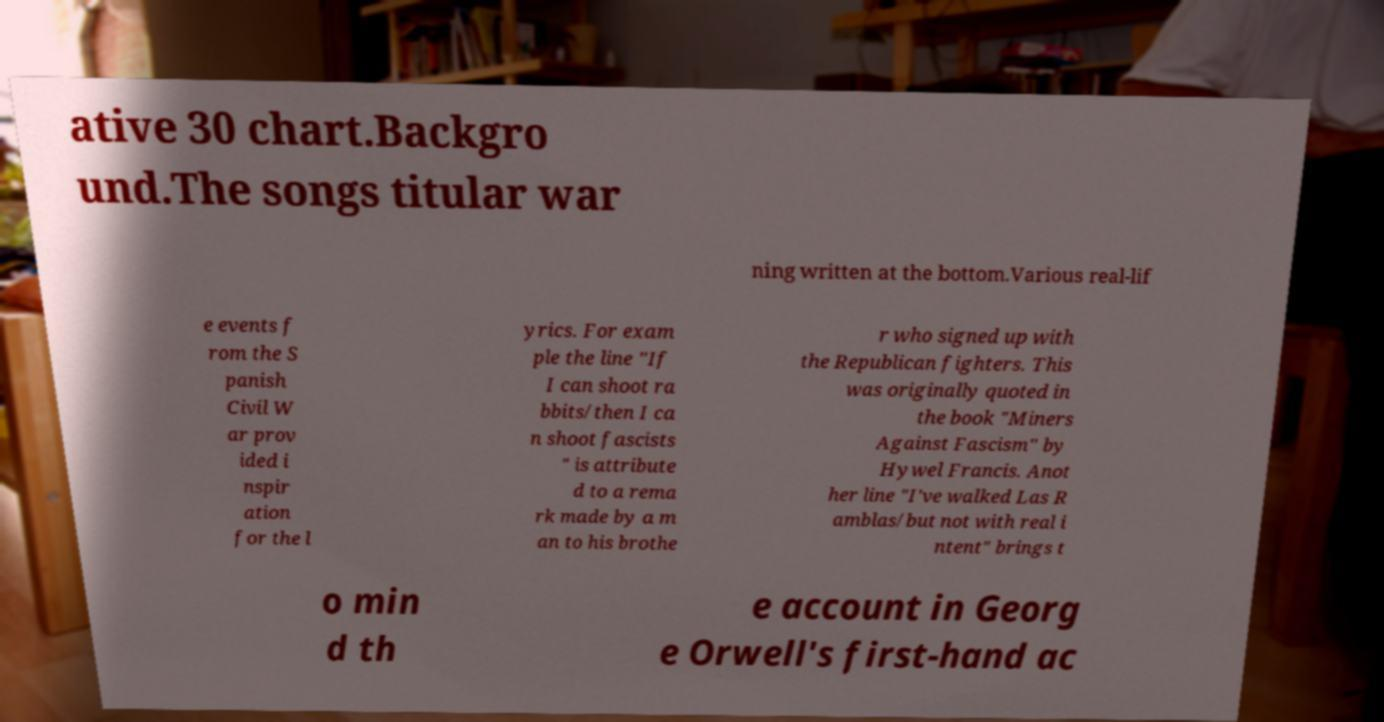I need the written content from this picture converted into text. Can you do that? ative 30 chart.Backgro und.The songs titular war ning written at the bottom.Various real-lif e events f rom the S panish Civil W ar prov ided i nspir ation for the l yrics. For exam ple the line "If I can shoot ra bbits/then I ca n shoot fascists " is attribute d to a rema rk made by a m an to his brothe r who signed up with the Republican fighters. This was originally quoted in the book "Miners Against Fascism" by Hywel Francis. Anot her line "I've walked Las R amblas/but not with real i ntent" brings t o min d th e account in Georg e Orwell's first-hand ac 